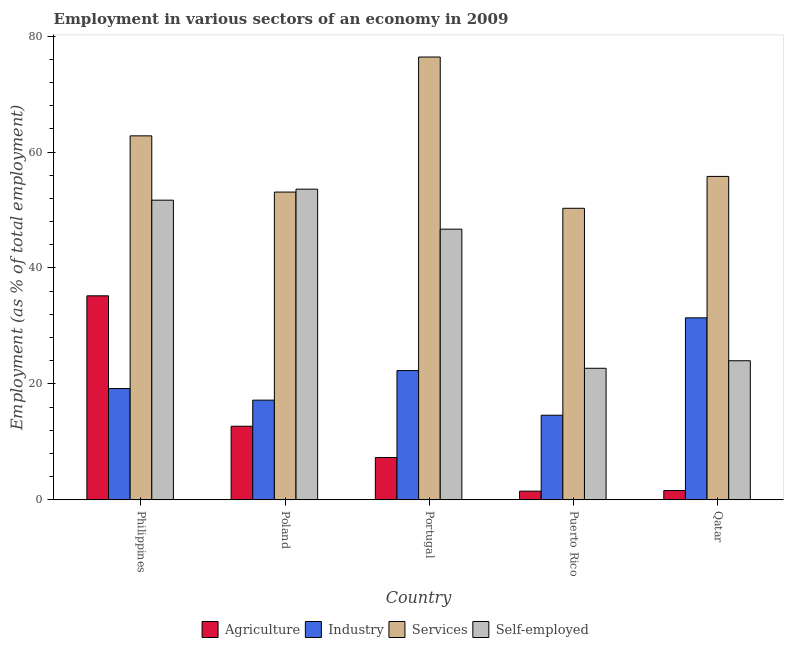How many different coloured bars are there?
Give a very brief answer. 4. How many groups of bars are there?
Your answer should be very brief. 5. Are the number of bars on each tick of the X-axis equal?
Offer a very short reply. Yes. What is the label of the 2nd group of bars from the left?
Give a very brief answer. Poland. What is the percentage of self employed workers in Portugal?
Offer a terse response. 46.7. Across all countries, what is the maximum percentage of workers in industry?
Offer a terse response. 31.4. Across all countries, what is the minimum percentage of workers in industry?
Provide a short and direct response. 14.6. In which country was the percentage of workers in industry minimum?
Your answer should be very brief. Puerto Rico. What is the total percentage of workers in industry in the graph?
Offer a terse response. 104.7. What is the difference between the percentage of workers in industry in Puerto Rico and that in Qatar?
Offer a terse response. -16.8. What is the difference between the percentage of self employed workers in Poland and the percentage of workers in industry in Philippines?
Offer a terse response. 34.4. What is the average percentage of workers in agriculture per country?
Your answer should be compact. 11.66. What is the difference between the percentage of self employed workers and percentage of workers in industry in Portugal?
Make the answer very short. 24.4. What is the ratio of the percentage of workers in services in Poland to that in Qatar?
Provide a short and direct response. 0.95. Is the percentage of self employed workers in Poland less than that in Puerto Rico?
Give a very brief answer. No. Is the difference between the percentage of workers in industry in Philippines and Qatar greater than the difference between the percentage of workers in services in Philippines and Qatar?
Give a very brief answer. No. What is the difference between the highest and the second highest percentage of workers in services?
Offer a very short reply. 13.6. What is the difference between the highest and the lowest percentage of workers in industry?
Offer a very short reply. 16.8. Is the sum of the percentage of workers in agriculture in Philippines and Qatar greater than the maximum percentage of workers in services across all countries?
Give a very brief answer. No. Is it the case that in every country, the sum of the percentage of self employed workers and percentage of workers in services is greater than the sum of percentage of workers in industry and percentage of workers in agriculture?
Keep it short and to the point. No. What does the 3rd bar from the left in Poland represents?
Your answer should be very brief. Services. What does the 2nd bar from the right in Philippines represents?
Ensure brevity in your answer.  Services. Are the values on the major ticks of Y-axis written in scientific E-notation?
Provide a short and direct response. No. Does the graph contain any zero values?
Provide a short and direct response. No. How many legend labels are there?
Provide a succinct answer. 4. What is the title of the graph?
Your answer should be very brief. Employment in various sectors of an economy in 2009. What is the label or title of the X-axis?
Offer a very short reply. Country. What is the label or title of the Y-axis?
Your response must be concise. Employment (as % of total employment). What is the Employment (as % of total employment) of Agriculture in Philippines?
Give a very brief answer. 35.2. What is the Employment (as % of total employment) of Industry in Philippines?
Make the answer very short. 19.2. What is the Employment (as % of total employment) of Services in Philippines?
Provide a short and direct response. 62.8. What is the Employment (as % of total employment) of Self-employed in Philippines?
Make the answer very short. 51.7. What is the Employment (as % of total employment) in Agriculture in Poland?
Offer a very short reply. 12.7. What is the Employment (as % of total employment) in Industry in Poland?
Your response must be concise. 17.2. What is the Employment (as % of total employment) in Services in Poland?
Offer a very short reply. 53.1. What is the Employment (as % of total employment) of Self-employed in Poland?
Your answer should be compact. 53.6. What is the Employment (as % of total employment) of Agriculture in Portugal?
Your answer should be very brief. 7.3. What is the Employment (as % of total employment) of Industry in Portugal?
Offer a terse response. 22.3. What is the Employment (as % of total employment) of Services in Portugal?
Your response must be concise. 76.4. What is the Employment (as % of total employment) in Self-employed in Portugal?
Offer a terse response. 46.7. What is the Employment (as % of total employment) in Agriculture in Puerto Rico?
Your response must be concise. 1.5. What is the Employment (as % of total employment) of Industry in Puerto Rico?
Give a very brief answer. 14.6. What is the Employment (as % of total employment) of Services in Puerto Rico?
Keep it short and to the point. 50.3. What is the Employment (as % of total employment) in Self-employed in Puerto Rico?
Provide a succinct answer. 22.7. What is the Employment (as % of total employment) in Agriculture in Qatar?
Keep it short and to the point. 1.6. What is the Employment (as % of total employment) in Industry in Qatar?
Provide a succinct answer. 31.4. What is the Employment (as % of total employment) in Services in Qatar?
Provide a succinct answer. 55.8. What is the Employment (as % of total employment) of Self-employed in Qatar?
Keep it short and to the point. 24. Across all countries, what is the maximum Employment (as % of total employment) in Agriculture?
Provide a short and direct response. 35.2. Across all countries, what is the maximum Employment (as % of total employment) in Industry?
Your response must be concise. 31.4. Across all countries, what is the maximum Employment (as % of total employment) of Services?
Offer a very short reply. 76.4. Across all countries, what is the maximum Employment (as % of total employment) in Self-employed?
Offer a very short reply. 53.6. Across all countries, what is the minimum Employment (as % of total employment) in Agriculture?
Offer a very short reply. 1.5. Across all countries, what is the minimum Employment (as % of total employment) of Industry?
Provide a short and direct response. 14.6. Across all countries, what is the minimum Employment (as % of total employment) in Services?
Keep it short and to the point. 50.3. Across all countries, what is the minimum Employment (as % of total employment) in Self-employed?
Ensure brevity in your answer.  22.7. What is the total Employment (as % of total employment) in Agriculture in the graph?
Keep it short and to the point. 58.3. What is the total Employment (as % of total employment) in Industry in the graph?
Your answer should be compact. 104.7. What is the total Employment (as % of total employment) of Services in the graph?
Give a very brief answer. 298.4. What is the total Employment (as % of total employment) in Self-employed in the graph?
Offer a very short reply. 198.7. What is the difference between the Employment (as % of total employment) of Agriculture in Philippines and that in Poland?
Make the answer very short. 22.5. What is the difference between the Employment (as % of total employment) of Agriculture in Philippines and that in Portugal?
Ensure brevity in your answer.  27.9. What is the difference between the Employment (as % of total employment) in Industry in Philippines and that in Portugal?
Provide a succinct answer. -3.1. What is the difference between the Employment (as % of total employment) of Self-employed in Philippines and that in Portugal?
Your answer should be compact. 5. What is the difference between the Employment (as % of total employment) in Agriculture in Philippines and that in Puerto Rico?
Give a very brief answer. 33.7. What is the difference between the Employment (as % of total employment) in Industry in Philippines and that in Puerto Rico?
Your response must be concise. 4.6. What is the difference between the Employment (as % of total employment) in Agriculture in Philippines and that in Qatar?
Make the answer very short. 33.6. What is the difference between the Employment (as % of total employment) in Industry in Philippines and that in Qatar?
Your answer should be very brief. -12.2. What is the difference between the Employment (as % of total employment) in Self-employed in Philippines and that in Qatar?
Keep it short and to the point. 27.7. What is the difference between the Employment (as % of total employment) in Services in Poland and that in Portugal?
Provide a short and direct response. -23.3. What is the difference between the Employment (as % of total employment) of Industry in Poland and that in Puerto Rico?
Your answer should be very brief. 2.6. What is the difference between the Employment (as % of total employment) in Services in Poland and that in Puerto Rico?
Ensure brevity in your answer.  2.8. What is the difference between the Employment (as % of total employment) of Self-employed in Poland and that in Puerto Rico?
Ensure brevity in your answer.  30.9. What is the difference between the Employment (as % of total employment) in Agriculture in Poland and that in Qatar?
Provide a short and direct response. 11.1. What is the difference between the Employment (as % of total employment) in Industry in Poland and that in Qatar?
Keep it short and to the point. -14.2. What is the difference between the Employment (as % of total employment) of Self-employed in Poland and that in Qatar?
Offer a very short reply. 29.6. What is the difference between the Employment (as % of total employment) in Agriculture in Portugal and that in Puerto Rico?
Your answer should be very brief. 5.8. What is the difference between the Employment (as % of total employment) in Services in Portugal and that in Puerto Rico?
Make the answer very short. 26.1. What is the difference between the Employment (as % of total employment) in Self-employed in Portugal and that in Puerto Rico?
Your response must be concise. 24. What is the difference between the Employment (as % of total employment) in Services in Portugal and that in Qatar?
Ensure brevity in your answer.  20.6. What is the difference between the Employment (as % of total employment) of Self-employed in Portugal and that in Qatar?
Give a very brief answer. 22.7. What is the difference between the Employment (as % of total employment) of Agriculture in Puerto Rico and that in Qatar?
Provide a short and direct response. -0.1. What is the difference between the Employment (as % of total employment) in Industry in Puerto Rico and that in Qatar?
Make the answer very short. -16.8. What is the difference between the Employment (as % of total employment) of Agriculture in Philippines and the Employment (as % of total employment) of Services in Poland?
Ensure brevity in your answer.  -17.9. What is the difference between the Employment (as % of total employment) in Agriculture in Philippines and the Employment (as % of total employment) in Self-employed in Poland?
Offer a very short reply. -18.4. What is the difference between the Employment (as % of total employment) of Industry in Philippines and the Employment (as % of total employment) of Services in Poland?
Ensure brevity in your answer.  -33.9. What is the difference between the Employment (as % of total employment) of Industry in Philippines and the Employment (as % of total employment) of Self-employed in Poland?
Provide a succinct answer. -34.4. What is the difference between the Employment (as % of total employment) of Agriculture in Philippines and the Employment (as % of total employment) of Industry in Portugal?
Provide a succinct answer. 12.9. What is the difference between the Employment (as % of total employment) in Agriculture in Philippines and the Employment (as % of total employment) in Services in Portugal?
Make the answer very short. -41.2. What is the difference between the Employment (as % of total employment) of Industry in Philippines and the Employment (as % of total employment) of Services in Portugal?
Provide a short and direct response. -57.2. What is the difference between the Employment (as % of total employment) of Industry in Philippines and the Employment (as % of total employment) of Self-employed in Portugal?
Offer a very short reply. -27.5. What is the difference between the Employment (as % of total employment) in Services in Philippines and the Employment (as % of total employment) in Self-employed in Portugal?
Provide a short and direct response. 16.1. What is the difference between the Employment (as % of total employment) of Agriculture in Philippines and the Employment (as % of total employment) of Industry in Puerto Rico?
Give a very brief answer. 20.6. What is the difference between the Employment (as % of total employment) in Agriculture in Philippines and the Employment (as % of total employment) in Services in Puerto Rico?
Provide a short and direct response. -15.1. What is the difference between the Employment (as % of total employment) of Industry in Philippines and the Employment (as % of total employment) of Services in Puerto Rico?
Provide a short and direct response. -31.1. What is the difference between the Employment (as % of total employment) in Industry in Philippines and the Employment (as % of total employment) in Self-employed in Puerto Rico?
Offer a terse response. -3.5. What is the difference between the Employment (as % of total employment) of Services in Philippines and the Employment (as % of total employment) of Self-employed in Puerto Rico?
Your answer should be very brief. 40.1. What is the difference between the Employment (as % of total employment) in Agriculture in Philippines and the Employment (as % of total employment) in Industry in Qatar?
Your answer should be very brief. 3.8. What is the difference between the Employment (as % of total employment) of Agriculture in Philippines and the Employment (as % of total employment) of Services in Qatar?
Provide a short and direct response. -20.6. What is the difference between the Employment (as % of total employment) of Agriculture in Philippines and the Employment (as % of total employment) of Self-employed in Qatar?
Provide a short and direct response. 11.2. What is the difference between the Employment (as % of total employment) in Industry in Philippines and the Employment (as % of total employment) in Services in Qatar?
Your answer should be compact. -36.6. What is the difference between the Employment (as % of total employment) in Industry in Philippines and the Employment (as % of total employment) in Self-employed in Qatar?
Your answer should be very brief. -4.8. What is the difference between the Employment (as % of total employment) in Services in Philippines and the Employment (as % of total employment) in Self-employed in Qatar?
Ensure brevity in your answer.  38.8. What is the difference between the Employment (as % of total employment) of Agriculture in Poland and the Employment (as % of total employment) of Industry in Portugal?
Provide a short and direct response. -9.6. What is the difference between the Employment (as % of total employment) of Agriculture in Poland and the Employment (as % of total employment) of Services in Portugal?
Give a very brief answer. -63.7. What is the difference between the Employment (as % of total employment) in Agriculture in Poland and the Employment (as % of total employment) in Self-employed in Portugal?
Offer a terse response. -34. What is the difference between the Employment (as % of total employment) of Industry in Poland and the Employment (as % of total employment) of Services in Portugal?
Provide a succinct answer. -59.2. What is the difference between the Employment (as % of total employment) of Industry in Poland and the Employment (as % of total employment) of Self-employed in Portugal?
Offer a terse response. -29.5. What is the difference between the Employment (as % of total employment) in Services in Poland and the Employment (as % of total employment) in Self-employed in Portugal?
Provide a succinct answer. 6.4. What is the difference between the Employment (as % of total employment) in Agriculture in Poland and the Employment (as % of total employment) in Industry in Puerto Rico?
Make the answer very short. -1.9. What is the difference between the Employment (as % of total employment) of Agriculture in Poland and the Employment (as % of total employment) of Services in Puerto Rico?
Provide a succinct answer. -37.6. What is the difference between the Employment (as % of total employment) of Agriculture in Poland and the Employment (as % of total employment) of Self-employed in Puerto Rico?
Provide a short and direct response. -10. What is the difference between the Employment (as % of total employment) in Industry in Poland and the Employment (as % of total employment) in Services in Puerto Rico?
Make the answer very short. -33.1. What is the difference between the Employment (as % of total employment) in Services in Poland and the Employment (as % of total employment) in Self-employed in Puerto Rico?
Your answer should be compact. 30.4. What is the difference between the Employment (as % of total employment) in Agriculture in Poland and the Employment (as % of total employment) in Industry in Qatar?
Offer a very short reply. -18.7. What is the difference between the Employment (as % of total employment) of Agriculture in Poland and the Employment (as % of total employment) of Services in Qatar?
Your answer should be very brief. -43.1. What is the difference between the Employment (as % of total employment) of Agriculture in Poland and the Employment (as % of total employment) of Self-employed in Qatar?
Your answer should be very brief. -11.3. What is the difference between the Employment (as % of total employment) of Industry in Poland and the Employment (as % of total employment) of Services in Qatar?
Your answer should be compact. -38.6. What is the difference between the Employment (as % of total employment) of Industry in Poland and the Employment (as % of total employment) of Self-employed in Qatar?
Offer a terse response. -6.8. What is the difference between the Employment (as % of total employment) in Services in Poland and the Employment (as % of total employment) in Self-employed in Qatar?
Provide a succinct answer. 29.1. What is the difference between the Employment (as % of total employment) of Agriculture in Portugal and the Employment (as % of total employment) of Industry in Puerto Rico?
Offer a terse response. -7.3. What is the difference between the Employment (as % of total employment) of Agriculture in Portugal and the Employment (as % of total employment) of Services in Puerto Rico?
Ensure brevity in your answer.  -43. What is the difference between the Employment (as % of total employment) in Agriculture in Portugal and the Employment (as % of total employment) in Self-employed in Puerto Rico?
Offer a terse response. -15.4. What is the difference between the Employment (as % of total employment) in Industry in Portugal and the Employment (as % of total employment) in Services in Puerto Rico?
Keep it short and to the point. -28. What is the difference between the Employment (as % of total employment) in Industry in Portugal and the Employment (as % of total employment) in Self-employed in Puerto Rico?
Offer a terse response. -0.4. What is the difference between the Employment (as % of total employment) in Services in Portugal and the Employment (as % of total employment) in Self-employed in Puerto Rico?
Offer a very short reply. 53.7. What is the difference between the Employment (as % of total employment) in Agriculture in Portugal and the Employment (as % of total employment) in Industry in Qatar?
Provide a short and direct response. -24.1. What is the difference between the Employment (as % of total employment) in Agriculture in Portugal and the Employment (as % of total employment) in Services in Qatar?
Your answer should be very brief. -48.5. What is the difference between the Employment (as % of total employment) of Agriculture in Portugal and the Employment (as % of total employment) of Self-employed in Qatar?
Offer a very short reply. -16.7. What is the difference between the Employment (as % of total employment) in Industry in Portugal and the Employment (as % of total employment) in Services in Qatar?
Your answer should be very brief. -33.5. What is the difference between the Employment (as % of total employment) of Services in Portugal and the Employment (as % of total employment) of Self-employed in Qatar?
Your answer should be very brief. 52.4. What is the difference between the Employment (as % of total employment) of Agriculture in Puerto Rico and the Employment (as % of total employment) of Industry in Qatar?
Your answer should be very brief. -29.9. What is the difference between the Employment (as % of total employment) in Agriculture in Puerto Rico and the Employment (as % of total employment) in Services in Qatar?
Offer a terse response. -54.3. What is the difference between the Employment (as % of total employment) of Agriculture in Puerto Rico and the Employment (as % of total employment) of Self-employed in Qatar?
Make the answer very short. -22.5. What is the difference between the Employment (as % of total employment) of Industry in Puerto Rico and the Employment (as % of total employment) of Services in Qatar?
Your answer should be compact. -41.2. What is the difference between the Employment (as % of total employment) of Services in Puerto Rico and the Employment (as % of total employment) of Self-employed in Qatar?
Give a very brief answer. 26.3. What is the average Employment (as % of total employment) of Agriculture per country?
Make the answer very short. 11.66. What is the average Employment (as % of total employment) of Industry per country?
Make the answer very short. 20.94. What is the average Employment (as % of total employment) in Services per country?
Provide a succinct answer. 59.68. What is the average Employment (as % of total employment) of Self-employed per country?
Your response must be concise. 39.74. What is the difference between the Employment (as % of total employment) of Agriculture and Employment (as % of total employment) of Industry in Philippines?
Provide a succinct answer. 16. What is the difference between the Employment (as % of total employment) in Agriculture and Employment (as % of total employment) in Services in Philippines?
Provide a short and direct response. -27.6. What is the difference between the Employment (as % of total employment) in Agriculture and Employment (as % of total employment) in Self-employed in Philippines?
Keep it short and to the point. -16.5. What is the difference between the Employment (as % of total employment) of Industry and Employment (as % of total employment) of Services in Philippines?
Your answer should be compact. -43.6. What is the difference between the Employment (as % of total employment) in Industry and Employment (as % of total employment) in Self-employed in Philippines?
Provide a short and direct response. -32.5. What is the difference between the Employment (as % of total employment) in Agriculture and Employment (as % of total employment) in Industry in Poland?
Your response must be concise. -4.5. What is the difference between the Employment (as % of total employment) of Agriculture and Employment (as % of total employment) of Services in Poland?
Provide a succinct answer. -40.4. What is the difference between the Employment (as % of total employment) of Agriculture and Employment (as % of total employment) of Self-employed in Poland?
Your answer should be very brief. -40.9. What is the difference between the Employment (as % of total employment) in Industry and Employment (as % of total employment) in Services in Poland?
Offer a terse response. -35.9. What is the difference between the Employment (as % of total employment) of Industry and Employment (as % of total employment) of Self-employed in Poland?
Provide a succinct answer. -36.4. What is the difference between the Employment (as % of total employment) of Services and Employment (as % of total employment) of Self-employed in Poland?
Keep it short and to the point. -0.5. What is the difference between the Employment (as % of total employment) of Agriculture and Employment (as % of total employment) of Services in Portugal?
Offer a terse response. -69.1. What is the difference between the Employment (as % of total employment) in Agriculture and Employment (as % of total employment) in Self-employed in Portugal?
Your answer should be very brief. -39.4. What is the difference between the Employment (as % of total employment) of Industry and Employment (as % of total employment) of Services in Portugal?
Provide a succinct answer. -54.1. What is the difference between the Employment (as % of total employment) of Industry and Employment (as % of total employment) of Self-employed in Portugal?
Offer a very short reply. -24.4. What is the difference between the Employment (as % of total employment) of Services and Employment (as % of total employment) of Self-employed in Portugal?
Your response must be concise. 29.7. What is the difference between the Employment (as % of total employment) of Agriculture and Employment (as % of total employment) of Services in Puerto Rico?
Your answer should be very brief. -48.8. What is the difference between the Employment (as % of total employment) in Agriculture and Employment (as % of total employment) in Self-employed in Puerto Rico?
Ensure brevity in your answer.  -21.2. What is the difference between the Employment (as % of total employment) in Industry and Employment (as % of total employment) in Services in Puerto Rico?
Your response must be concise. -35.7. What is the difference between the Employment (as % of total employment) of Industry and Employment (as % of total employment) of Self-employed in Puerto Rico?
Your response must be concise. -8.1. What is the difference between the Employment (as % of total employment) in Services and Employment (as % of total employment) in Self-employed in Puerto Rico?
Ensure brevity in your answer.  27.6. What is the difference between the Employment (as % of total employment) in Agriculture and Employment (as % of total employment) in Industry in Qatar?
Your answer should be very brief. -29.8. What is the difference between the Employment (as % of total employment) of Agriculture and Employment (as % of total employment) of Services in Qatar?
Provide a succinct answer. -54.2. What is the difference between the Employment (as % of total employment) of Agriculture and Employment (as % of total employment) of Self-employed in Qatar?
Offer a terse response. -22.4. What is the difference between the Employment (as % of total employment) of Industry and Employment (as % of total employment) of Services in Qatar?
Ensure brevity in your answer.  -24.4. What is the difference between the Employment (as % of total employment) of Services and Employment (as % of total employment) of Self-employed in Qatar?
Your answer should be compact. 31.8. What is the ratio of the Employment (as % of total employment) of Agriculture in Philippines to that in Poland?
Give a very brief answer. 2.77. What is the ratio of the Employment (as % of total employment) of Industry in Philippines to that in Poland?
Offer a very short reply. 1.12. What is the ratio of the Employment (as % of total employment) of Services in Philippines to that in Poland?
Provide a short and direct response. 1.18. What is the ratio of the Employment (as % of total employment) in Self-employed in Philippines to that in Poland?
Your response must be concise. 0.96. What is the ratio of the Employment (as % of total employment) in Agriculture in Philippines to that in Portugal?
Offer a very short reply. 4.82. What is the ratio of the Employment (as % of total employment) in Industry in Philippines to that in Portugal?
Ensure brevity in your answer.  0.86. What is the ratio of the Employment (as % of total employment) of Services in Philippines to that in Portugal?
Your answer should be very brief. 0.82. What is the ratio of the Employment (as % of total employment) of Self-employed in Philippines to that in Portugal?
Offer a very short reply. 1.11. What is the ratio of the Employment (as % of total employment) in Agriculture in Philippines to that in Puerto Rico?
Provide a succinct answer. 23.47. What is the ratio of the Employment (as % of total employment) in Industry in Philippines to that in Puerto Rico?
Ensure brevity in your answer.  1.32. What is the ratio of the Employment (as % of total employment) of Services in Philippines to that in Puerto Rico?
Your answer should be very brief. 1.25. What is the ratio of the Employment (as % of total employment) of Self-employed in Philippines to that in Puerto Rico?
Keep it short and to the point. 2.28. What is the ratio of the Employment (as % of total employment) of Agriculture in Philippines to that in Qatar?
Your answer should be very brief. 22. What is the ratio of the Employment (as % of total employment) in Industry in Philippines to that in Qatar?
Give a very brief answer. 0.61. What is the ratio of the Employment (as % of total employment) in Services in Philippines to that in Qatar?
Keep it short and to the point. 1.13. What is the ratio of the Employment (as % of total employment) of Self-employed in Philippines to that in Qatar?
Your answer should be compact. 2.15. What is the ratio of the Employment (as % of total employment) in Agriculture in Poland to that in Portugal?
Offer a terse response. 1.74. What is the ratio of the Employment (as % of total employment) of Industry in Poland to that in Portugal?
Your answer should be very brief. 0.77. What is the ratio of the Employment (as % of total employment) of Services in Poland to that in Portugal?
Offer a very short reply. 0.69. What is the ratio of the Employment (as % of total employment) of Self-employed in Poland to that in Portugal?
Keep it short and to the point. 1.15. What is the ratio of the Employment (as % of total employment) of Agriculture in Poland to that in Puerto Rico?
Give a very brief answer. 8.47. What is the ratio of the Employment (as % of total employment) in Industry in Poland to that in Puerto Rico?
Offer a terse response. 1.18. What is the ratio of the Employment (as % of total employment) of Services in Poland to that in Puerto Rico?
Give a very brief answer. 1.06. What is the ratio of the Employment (as % of total employment) in Self-employed in Poland to that in Puerto Rico?
Offer a very short reply. 2.36. What is the ratio of the Employment (as % of total employment) of Agriculture in Poland to that in Qatar?
Give a very brief answer. 7.94. What is the ratio of the Employment (as % of total employment) in Industry in Poland to that in Qatar?
Your response must be concise. 0.55. What is the ratio of the Employment (as % of total employment) of Services in Poland to that in Qatar?
Make the answer very short. 0.95. What is the ratio of the Employment (as % of total employment) in Self-employed in Poland to that in Qatar?
Keep it short and to the point. 2.23. What is the ratio of the Employment (as % of total employment) in Agriculture in Portugal to that in Puerto Rico?
Your response must be concise. 4.87. What is the ratio of the Employment (as % of total employment) of Industry in Portugal to that in Puerto Rico?
Ensure brevity in your answer.  1.53. What is the ratio of the Employment (as % of total employment) of Services in Portugal to that in Puerto Rico?
Offer a very short reply. 1.52. What is the ratio of the Employment (as % of total employment) of Self-employed in Portugal to that in Puerto Rico?
Give a very brief answer. 2.06. What is the ratio of the Employment (as % of total employment) in Agriculture in Portugal to that in Qatar?
Your answer should be compact. 4.56. What is the ratio of the Employment (as % of total employment) of Industry in Portugal to that in Qatar?
Your answer should be very brief. 0.71. What is the ratio of the Employment (as % of total employment) of Services in Portugal to that in Qatar?
Your answer should be very brief. 1.37. What is the ratio of the Employment (as % of total employment) of Self-employed in Portugal to that in Qatar?
Your response must be concise. 1.95. What is the ratio of the Employment (as % of total employment) in Agriculture in Puerto Rico to that in Qatar?
Your answer should be very brief. 0.94. What is the ratio of the Employment (as % of total employment) in Industry in Puerto Rico to that in Qatar?
Ensure brevity in your answer.  0.47. What is the ratio of the Employment (as % of total employment) of Services in Puerto Rico to that in Qatar?
Ensure brevity in your answer.  0.9. What is the ratio of the Employment (as % of total employment) of Self-employed in Puerto Rico to that in Qatar?
Offer a very short reply. 0.95. What is the difference between the highest and the second highest Employment (as % of total employment) in Industry?
Provide a succinct answer. 9.1. What is the difference between the highest and the lowest Employment (as % of total employment) of Agriculture?
Keep it short and to the point. 33.7. What is the difference between the highest and the lowest Employment (as % of total employment) of Industry?
Ensure brevity in your answer.  16.8. What is the difference between the highest and the lowest Employment (as % of total employment) in Services?
Your answer should be compact. 26.1. What is the difference between the highest and the lowest Employment (as % of total employment) of Self-employed?
Your answer should be compact. 30.9. 